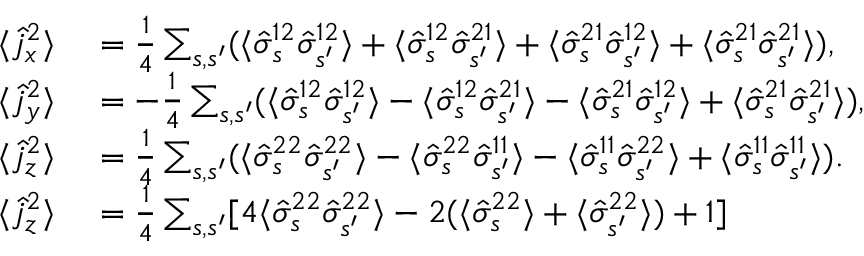<formula> <loc_0><loc_0><loc_500><loc_500>\begin{array} { r l } { \langle \hat { j } _ { x } ^ { 2 } \rangle } & = \frac { 1 } { 4 } \sum _ { s , s ^ { \prime } } ( \langle \hat { \sigma } _ { s } ^ { 1 2 } \hat { \sigma } _ { s ^ { \prime } } ^ { 1 2 } \rangle + \langle \hat { \sigma } _ { s } ^ { 1 2 } \hat { \sigma } _ { s ^ { \prime } } ^ { 2 1 } \rangle + \langle \hat { \sigma } _ { s } ^ { 2 1 } \hat { \sigma } _ { s ^ { \prime } } ^ { 1 2 } \rangle + \langle \hat { \sigma } _ { s } ^ { 2 1 } \hat { \sigma } _ { s ^ { \prime } } ^ { 2 1 } \rangle ) , } \\ { \langle \hat { j } _ { y } ^ { 2 } \rangle } & = - \frac { 1 } { 4 } \sum _ { s , s ^ { \prime } } ( \langle \hat { \sigma } _ { s } ^ { 1 2 } \hat { \sigma } _ { s ^ { \prime } } ^ { 1 2 } \rangle - \langle \hat { \sigma } _ { s } ^ { 1 2 } \hat { \sigma } _ { s ^ { \prime } } ^ { 2 1 } \rangle - \langle \hat { \sigma } _ { s } ^ { 2 1 } \hat { \sigma } _ { s ^ { \prime } } ^ { 1 2 } \rangle + \langle \hat { \sigma } _ { s } ^ { 2 1 } \hat { \sigma } _ { s ^ { \prime } } ^ { 2 1 } \rangle ) , } \\ { \langle \hat { j } _ { z } ^ { 2 } \rangle } & = \frac { 1 } { 4 } \sum _ { s , s ^ { \prime } } ( \langle \hat { \sigma } _ { s } ^ { 2 2 } \hat { \sigma } _ { s ^ { \prime } } ^ { 2 2 } \rangle - \langle \hat { \sigma } _ { s } ^ { 2 2 } \hat { \sigma } _ { s ^ { \prime } } ^ { 1 1 } \rangle - \langle \hat { \sigma } _ { s } ^ { 1 1 } \hat { \sigma } _ { s ^ { \prime } } ^ { 2 2 } \rangle + \langle \hat { \sigma } _ { s } ^ { 1 1 } \hat { \sigma } _ { s ^ { \prime } } ^ { 1 1 } \rangle ) . } \\ { \langle \hat { j } _ { z } ^ { 2 } \rangle } & = \frac { 1 } { 4 } \sum _ { s , s ^ { \prime } } [ 4 \langle \hat { \sigma } _ { s } ^ { 2 2 } \hat { \sigma } _ { s ^ { \prime } } ^ { 2 2 } \rangle - 2 ( \langle \hat { \sigma } _ { s } ^ { 2 2 } \rangle + \langle \hat { \sigma } _ { s ^ { \prime } } ^ { 2 2 } \rangle ) + 1 ] } \end{array}</formula> 